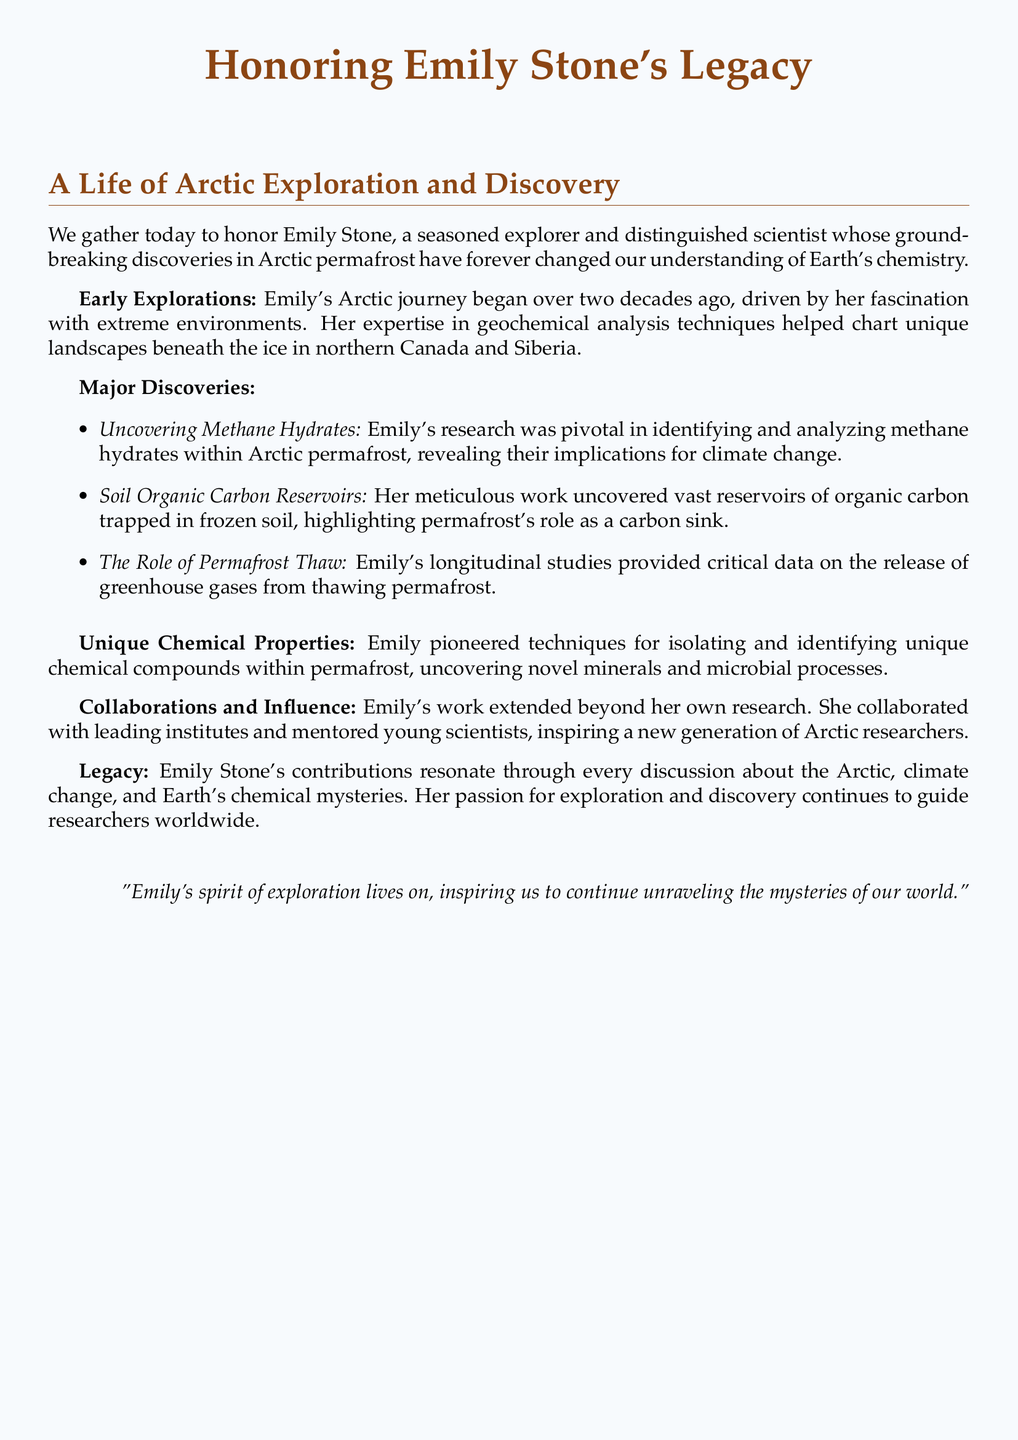What is Emily Stone known for? Emily Stone is known for her groundbreaking discoveries in Arctic permafrost and its unique chemical properties.
Answer: Groundbreaking discoveries in Arctic permafrost How many years has Emily been exploring the Arctic? Emily's Arctic journey began over two decades ago, indicating she has been exploring for at least 20 years.
Answer: Over two decades What unique compound did Emily's research reveal? Emily pioneered techniques for isolating and identifying unique chemical compounds within permafrost, which includes novel minerals and microbial processes.
Answer: Unique chemical compounds What was one of Emily's major discoveries related to climate change? One of Emily's major discoveries was the identification and analysis of methane hydrates within Arctic permafrost, which has implications for climate change.
Answer: Methane hydrates Who did Emily collaborate with? Emily collaborated with leading institutes and mentored young scientists.
Answer: Leading institutes What did Emily uncover in frozen soil? Emily's meticulous work uncovered vast reservoirs of organic carbon trapped in frozen soil.
Answer: Vast reservoirs of organic carbon How did Emily contribute to understanding greenhouse gases? Emily's longitudinal studies provided critical data on the release of greenhouse gases from thawing permafrost.
Answer: Release of greenhouse gases What is the main theme of Emily's legacy? Emily Stone's contributions resonate through every discussion about the Arctic, climate change, and Earth's chemical mysteries, reflecting her lasting impact.
Answer: Climate change and Earth's chemical mysteries 